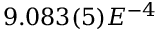Convert formula to latex. <formula><loc_0><loc_0><loc_500><loc_500>9 . 0 8 3 ( 5 ) E ^ { - 4 }</formula> 